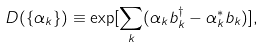<formula> <loc_0><loc_0><loc_500><loc_500>D ( \{ \alpha _ { k } \} ) \equiv \exp [ \sum _ { k } ( \alpha _ { k } b ^ { \dagger } _ { k } - \alpha ^ { * } _ { k } b _ { k } ) ] ,</formula> 